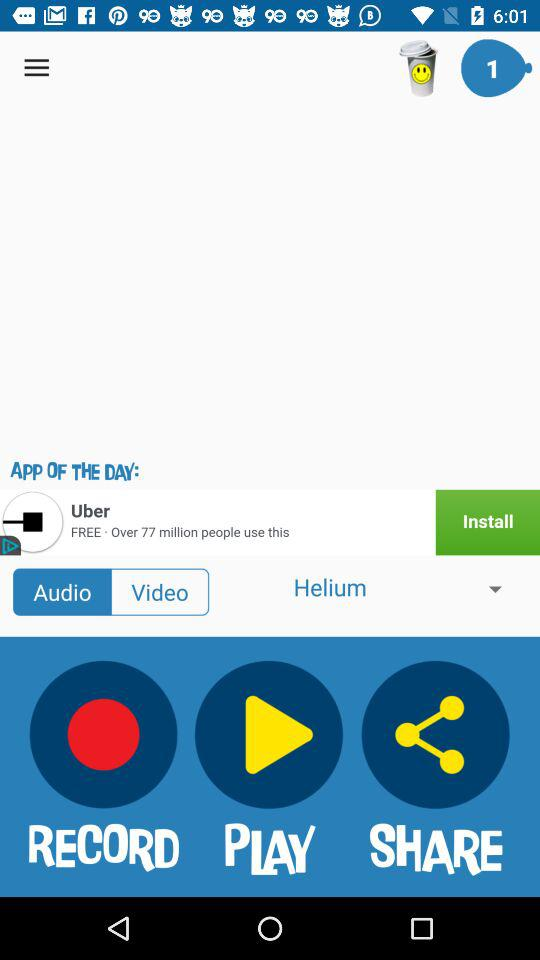Which button has been selected? The selected button is "Audio". 